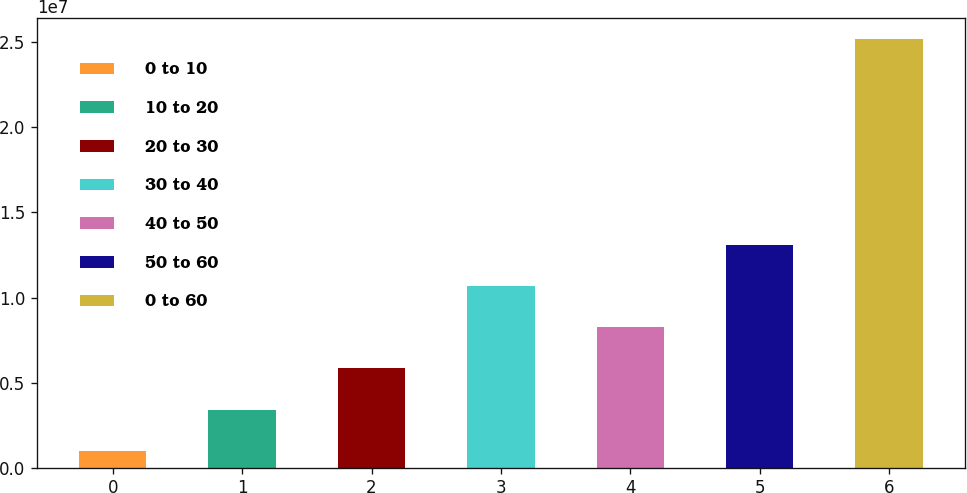<chart> <loc_0><loc_0><loc_500><loc_500><bar_chart><fcel>0 to 10<fcel>10 to 20<fcel>20 to 30<fcel>30 to 40<fcel>40 to 50<fcel>50 to 60<fcel>0 to 60<nl><fcel>1.002e+06<fcel>3.4186e+06<fcel>5.8352e+06<fcel>1.06684e+07<fcel>8.2518e+06<fcel>1.3085e+07<fcel>2.5168e+07<nl></chart> 